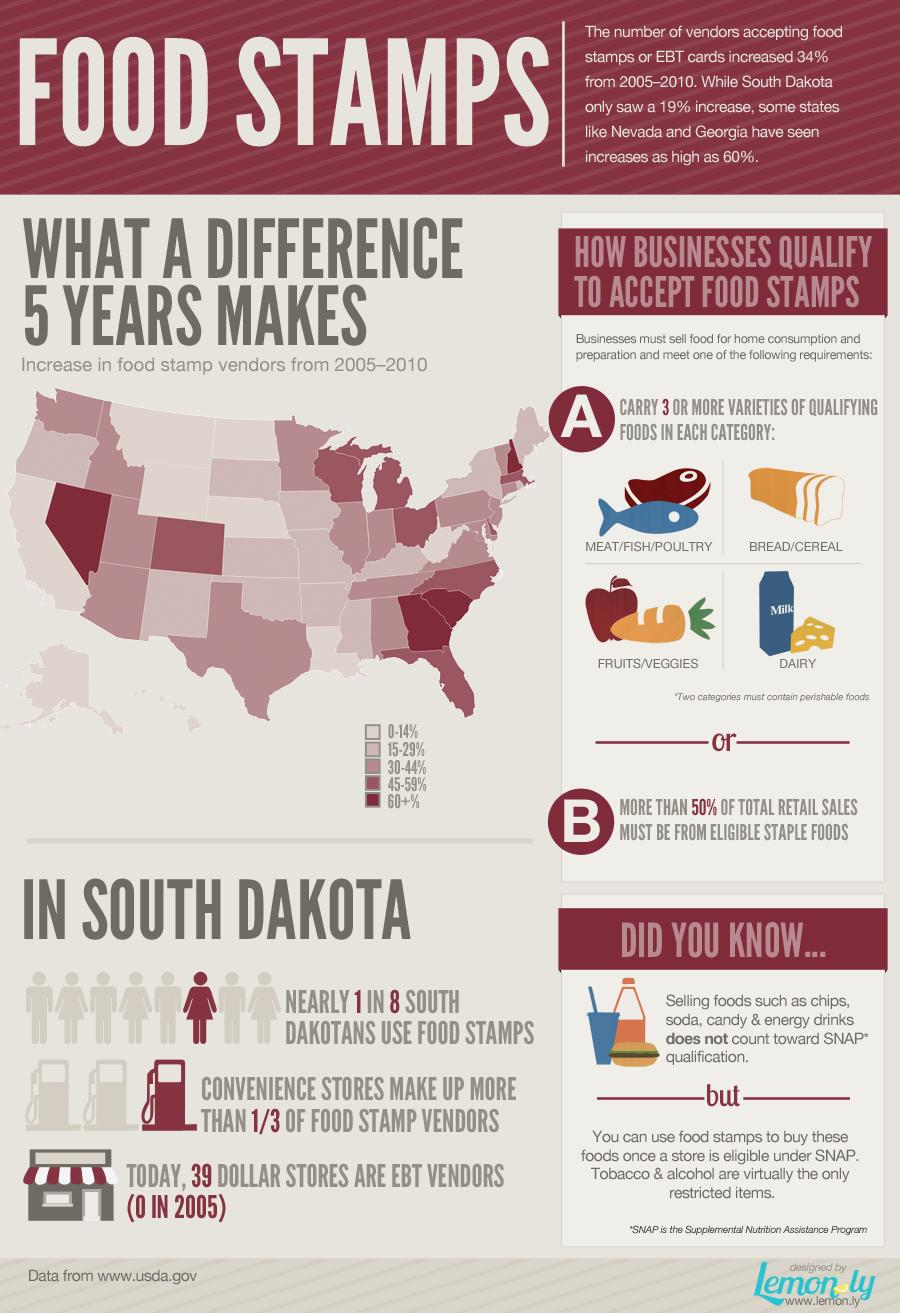Point out several critical features in this image. There is only one condition that a business must meet in order to qualify to accept food stamps. 